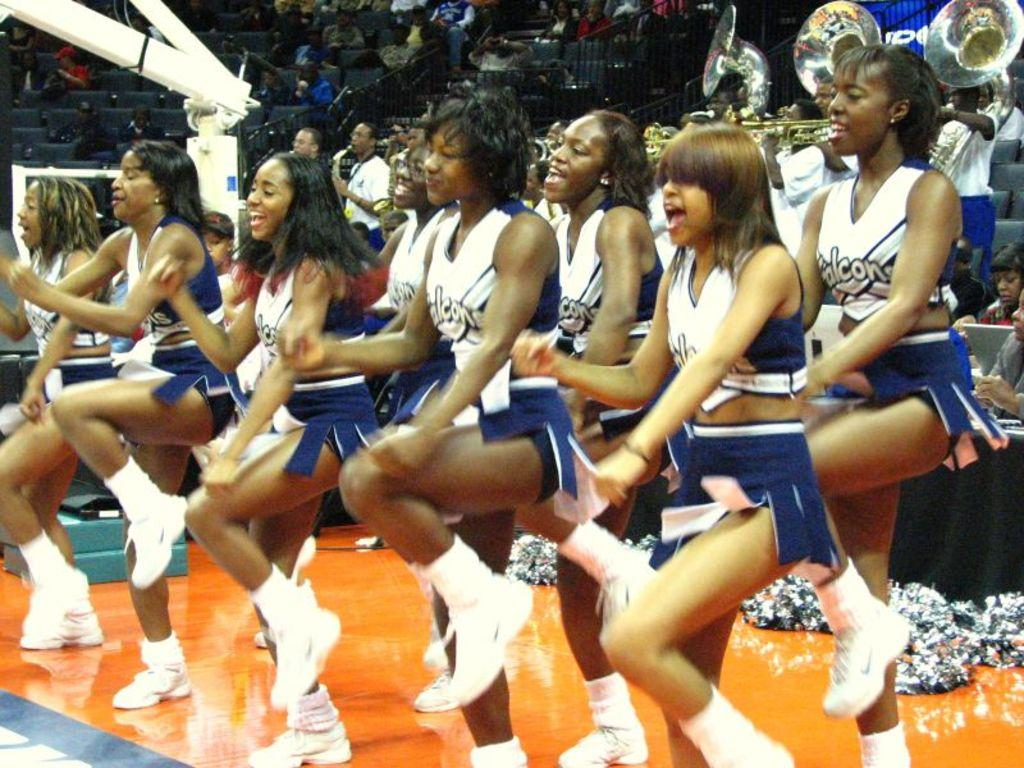<image>
Present a compact description of the photo's key features. The cheer leaders are doing their best to cheer on the Falcons. 